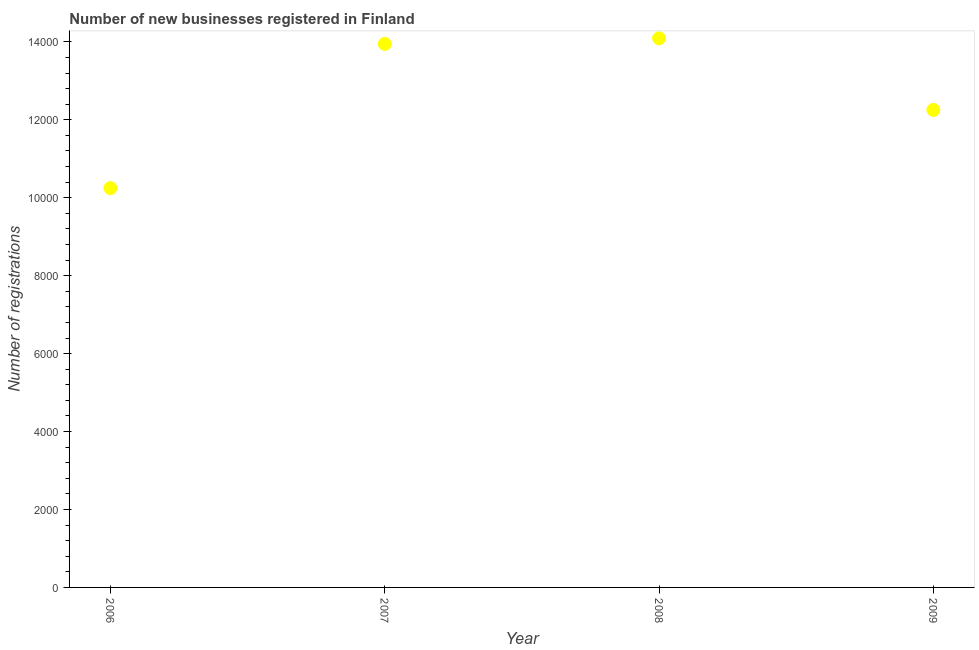What is the number of new business registrations in 2009?
Your answer should be compact. 1.23e+04. Across all years, what is the maximum number of new business registrations?
Keep it short and to the point. 1.41e+04. Across all years, what is the minimum number of new business registrations?
Provide a succinct answer. 1.02e+04. In which year was the number of new business registrations maximum?
Provide a short and direct response. 2008. What is the sum of the number of new business registrations?
Your answer should be compact. 5.05e+04. What is the difference between the number of new business registrations in 2007 and 2008?
Offer a very short reply. -143. What is the average number of new business registrations per year?
Give a very brief answer. 1.26e+04. What is the median number of new business registrations?
Make the answer very short. 1.31e+04. What is the ratio of the number of new business registrations in 2007 to that in 2008?
Give a very brief answer. 0.99. Is the number of new business registrations in 2007 less than that in 2008?
Your answer should be very brief. Yes. What is the difference between the highest and the second highest number of new business registrations?
Ensure brevity in your answer.  143. Is the sum of the number of new business registrations in 2007 and 2008 greater than the maximum number of new business registrations across all years?
Keep it short and to the point. Yes. What is the difference between the highest and the lowest number of new business registrations?
Your answer should be compact. 3844. How many years are there in the graph?
Give a very brief answer. 4. What is the difference between two consecutive major ticks on the Y-axis?
Keep it short and to the point. 2000. What is the title of the graph?
Offer a terse response. Number of new businesses registered in Finland. What is the label or title of the Y-axis?
Your response must be concise. Number of registrations. What is the Number of registrations in 2006?
Make the answer very short. 1.02e+04. What is the Number of registrations in 2007?
Keep it short and to the point. 1.39e+04. What is the Number of registrations in 2008?
Ensure brevity in your answer.  1.41e+04. What is the Number of registrations in 2009?
Ensure brevity in your answer.  1.23e+04. What is the difference between the Number of registrations in 2006 and 2007?
Keep it short and to the point. -3701. What is the difference between the Number of registrations in 2006 and 2008?
Your answer should be compact. -3844. What is the difference between the Number of registrations in 2006 and 2009?
Provide a short and direct response. -2007. What is the difference between the Number of registrations in 2007 and 2008?
Your response must be concise. -143. What is the difference between the Number of registrations in 2007 and 2009?
Make the answer very short. 1694. What is the difference between the Number of registrations in 2008 and 2009?
Offer a very short reply. 1837. What is the ratio of the Number of registrations in 2006 to that in 2007?
Ensure brevity in your answer.  0.73. What is the ratio of the Number of registrations in 2006 to that in 2008?
Provide a succinct answer. 0.73. What is the ratio of the Number of registrations in 2006 to that in 2009?
Provide a succinct answer. 0.84. What is the ratio of the Number of registrations in 2007 to that in 2009?
Ensure brevity in your answer.  1.14. What is the ratio of the Number of registrations in 2008 to that in 2009?
Make the answer very short. 1.15. 